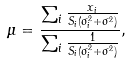<formula> <loc_0><loc_0><loc_500><loc_500>\mu = \frac { \sum _ { i } \frac { x _ { i } } { S _ { i } ( \sigma _ { i } ^ { 2 } + \sigma ^ { 2 } ) } } { \sum _ { i } \frac { 1 } { S _ { i } ( \sigma _ { i } ^ { 2 } + \sigma ^ { 2 } ) } } ,</formula> 